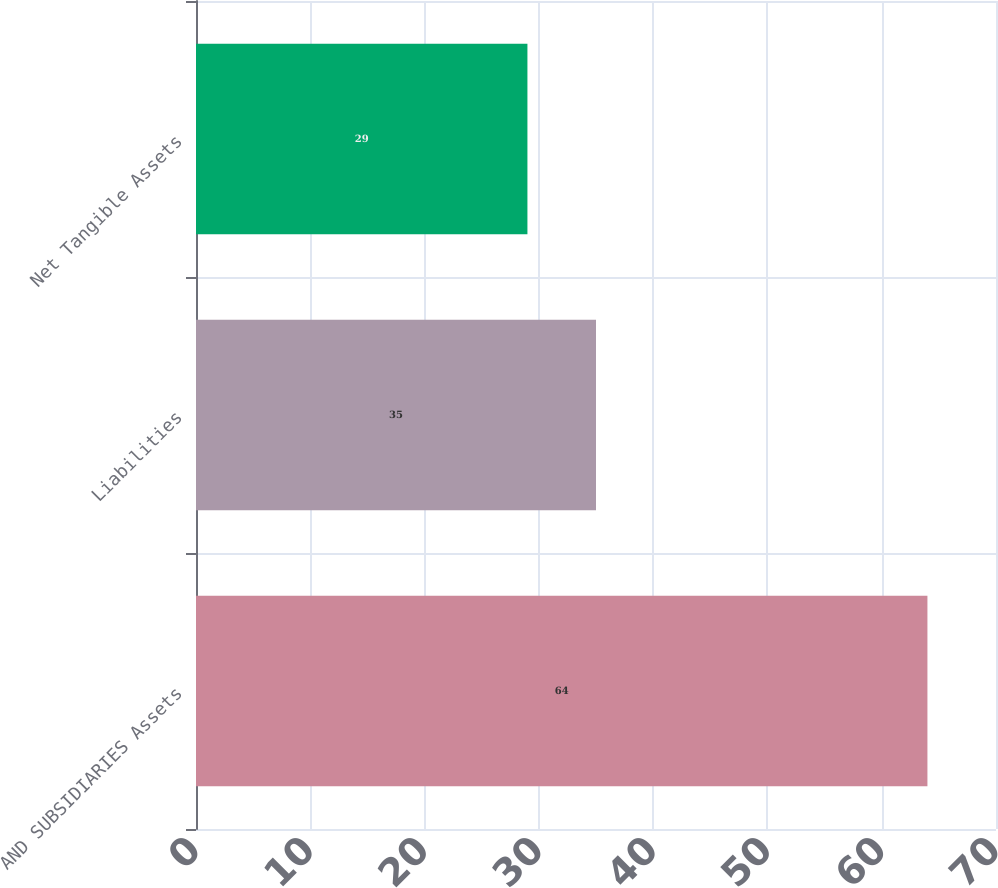Convert chart. <chart><loc_0><loc_0><loc_500><loc_500><bar_chart><fcel>AND SUBSIDIARIES Assets<fcel>Liabilities<fcel>Net Tangible Assets<nl><fcel>64<fcel>35<fcel>29<nl></chart> 